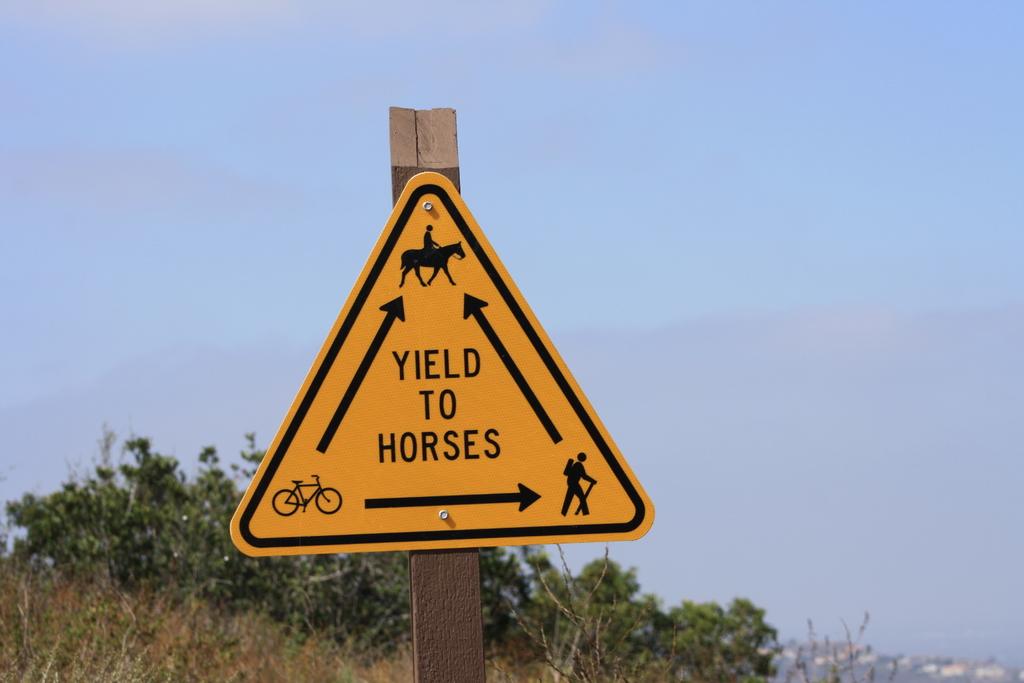What animal is mentioned on the sign?
Provide a short and direct response. Horses. 